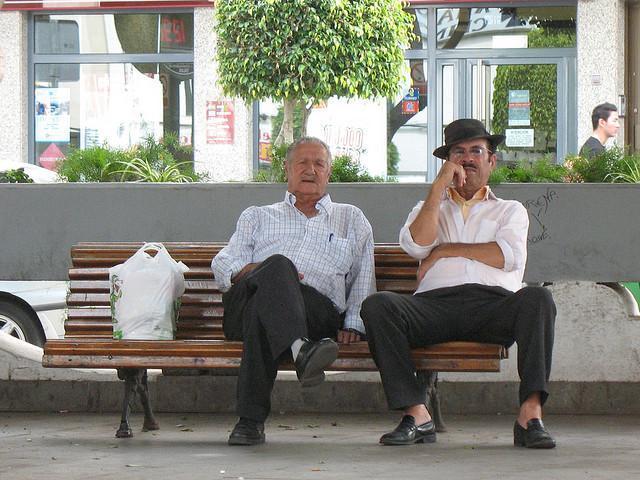How many people are there?
Give a very brief answer. 2. How many cats have a banana in their paws?
Give a very brief answer. 0. 